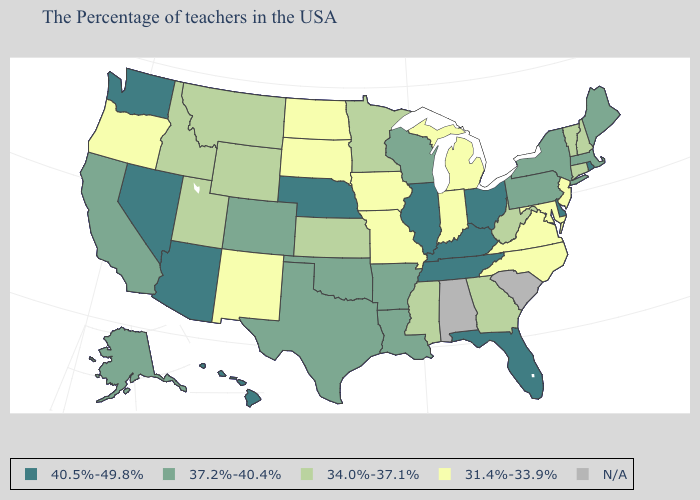What is the value of Kansas?
Give a very brief answer. 34.0%-37.1%. Name the states that have a value in the range 31.4%-33.9%?
Be succinct. New Jersey, Maryland, Virginia, North Carolina, Michigan, Indiana, Missouri, Iowa, South Dakota, North Dakota, New Mexico, Oregon. Name the states that have a value in the range 34.0%-37.1%?
Give a very brief answer. New Hampshire, Vermont, Connecticut, West Virginia, Georgia, Mississippi, Minnesota, Kansas, Wyoming, Utah, Montana, Idaho. What is the value of Georgia?
Quick response, please. 34.0%-37.1%. Name the states that have a value in the range 40.5%-49.8%?
Be succinct. Rhode Island, Delaware, Ohio, Florida, Kentucky, Tennessee, Illinois, Nebraska, Arizona, Nevada, Washington, Hawaii. What is the highest value in states that border Indiana?
Keep it brief. 40.5%-49.8%. Does North Dakota have the highest value in the USA?
Quick response, please. No. What is the value of Connecticut?
Quick response, please. 34.0%-37.1%. Name the states that have a value in the range N/A?
Short answer required. South Carolina, Alabama. Among the states that border Rhode Island , which have the highest value?
Quick response, please. Massachusetts. Among the states that border Missouri , does Iowa have the highest value?
Give a very brief answer. No. Name the states that have a value in the range 31.4%-33.9%?
Write a very short answer. New Jersey, Maryland, Virginia, North Carolina, Michigan, Indiana, Missouri, Iowa, South Dakota, North Dakota, New Mexico, Oregon. Name the states that have a value in the range 37.2%-40.4%?
Concise answer only. Maine, Massachusetts, New York, Pennsylvania, Wisconsin, Louisiana, Arkansas, Oklahoma, Texas, Colorado, California, Alaska. What is the value of Oregon?
Concise answer only. 31.4%-33.9%. 